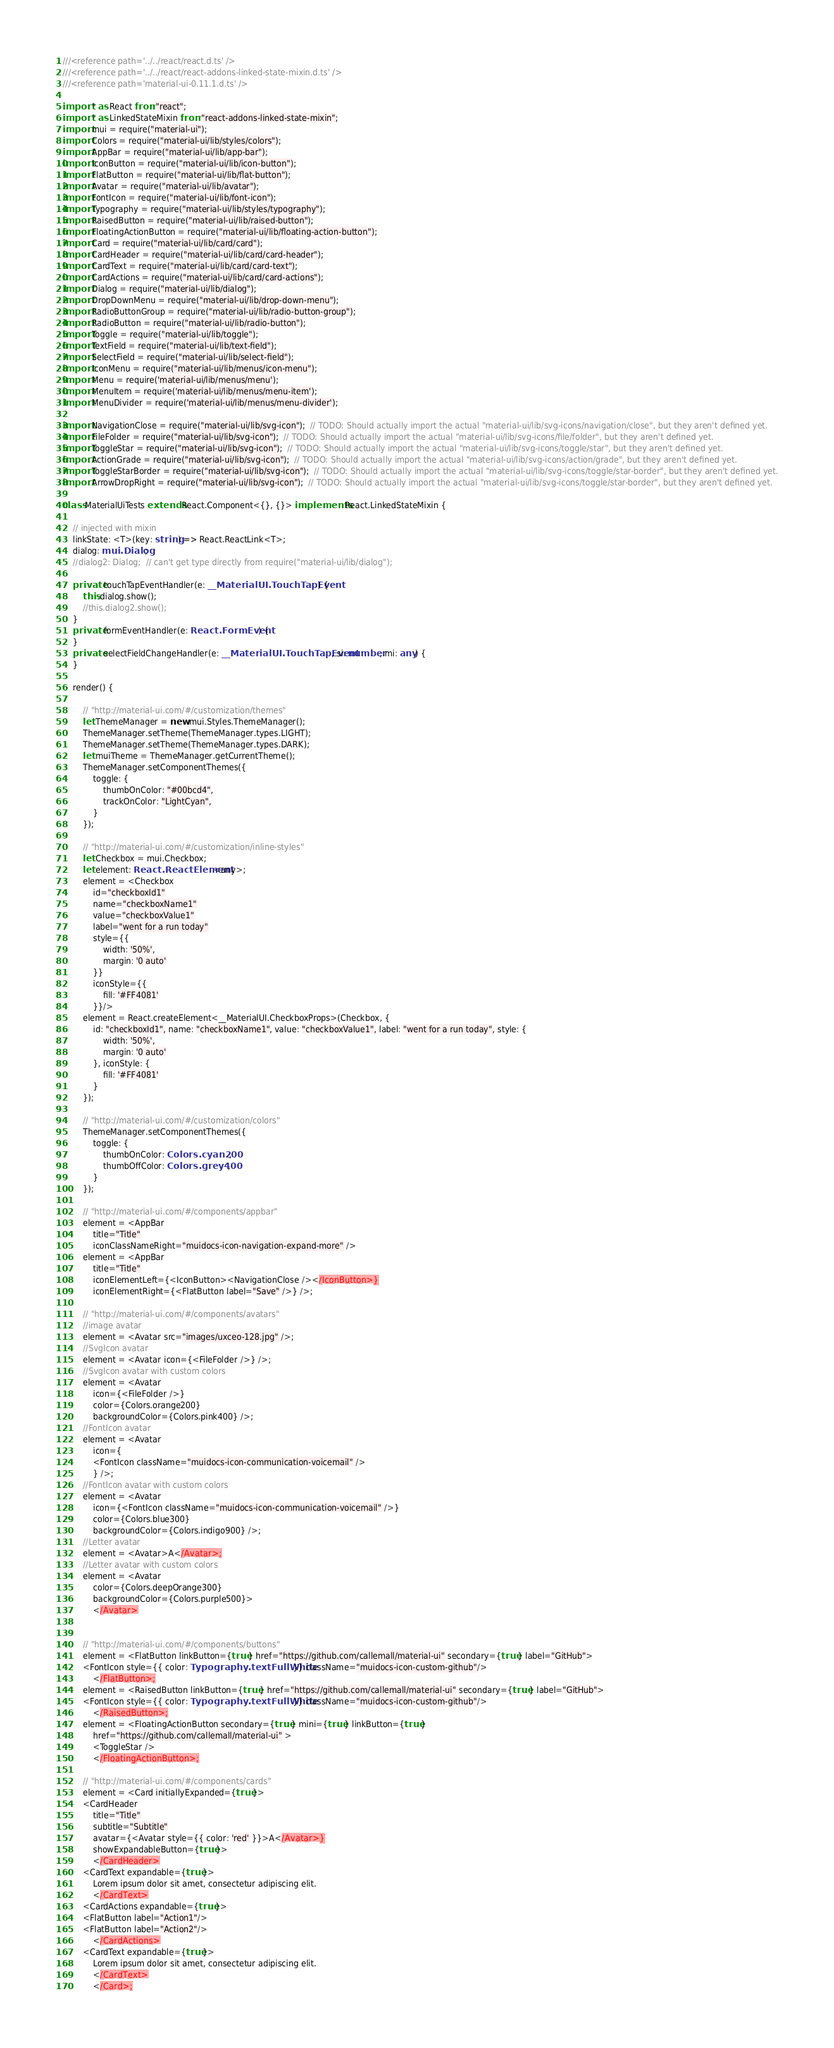Convert code to text. <code><loc_0><loc_0><loc_500><loc_500><_TypeScript_>///<reference path='../../react/react.d.ts' />
///<reference path='../../react/react-addons-linked-state-mixin.d.ts' />
///<reference path='material-ui-0.11.1.d.ts' />

import * as React from "react";
import * as LinkedStateMixin from "react-addons-linked-state-mixin";
import mui = require("material-ui");
import Colors = require("material-ui/lib/styles/colors");
import AppBar = require("material-ui/lib/app-bar");
import IconButton = require("material-ui/lib/icon-button");
import FlatButton = require("material-ui/lib/flat-button");
import Avatar = require("material-ui/lib/avatar");
import FontIcon = require("material-ui/lib/font-icon");
import Typography = require("material-ui/lib/styles/typography");
import RaisedButton = require("material-ui/lib/raised-button");
import FloatingActionButton = require("material-ui/lib/floating-action-button");
import Card = require("material-ui/lib/card/card");
import CardHeader = require("material-ui/lib/card/card-header");
import CardText = require("material-ui/lib/card/card-text");
import CardActions = require("material-ui/lib/card/card-actions");
import Dialog = require("material-ui/lib/dialog");
import DropDownMenu = require("material-ui/lib/drop-down-menu");
import RadioButtonGroup = require("material-ui/lib/radio-button-group");
import RadioButton = require("material-ui/lib/radio-button");
import Toggle = require("material-ui/lib/toggle");
import TextField = require("material-ui/lib/text-field");
import SelectField = require("material-ui/lib/select-field");
import IconMenu = require("material-ui/lib/menus/icon-menu");
import Menu = require('material-ui/lib/menus/menu');
import MenuItem = require('material-ui/lib/menus/menu-item');
import MenuDivider = require('material-ui/lib/menus/menu-divider');

import NavigationClose = require("material-ui/lib/svg-icon");  // TODO: Should actually import the actual "material-ui/lib/svg-icons/navigation/close", but they aren't defined yet.
import FileFolder = require("material-ui/lib/svg-icon");  // TODO: Should actually import the actual "material-ui/lib/svg-icons/file/folder", but they aren't defined yet.
import ToggleStar = require("material-ui/lib/svg-icon");  // TODO: Should actually import the actual "material-ui/lib/svg-icons/toggle/star", but they aren't defined yet.
import ActionGrade = require("material-ui/lib/svg-icon");  // TODO: Should actually import the actual "material-ui/lib/svg-icons/action/grade", but they aren't defined yet.
import ToggleStarBorder = require("material-ui/lib/svg-icon");  // TODO: Should actually import the actual "material-ui/lib/svg-icons/toggle/star-border", but they aren't defined yet.
import ArrowDropRight = require("material-ui/lib/svg-icon");  // TODO: Should actually import the actual "material-ui/lib/svg-icons/toggle/star-border", but they aren't defined yet.

class MaterialUiTests extends React.Component<{}, {}> implements React.LinkedStateMixin {

    // injected with mixin
    linkState: <T>(key: string) => React.ReactLink<T>;
    dialog: mui.Dialog;
    //dialog2: Dialog;  // can't get type directly from require("material-ui/lib/dialog");

    private touchTapEventHandler(e: __MaterialUI.TouchTapEvent) {
        this.dialog.show();
        //this.dialog2.show();
    }
    private formEventHandler(e: React.FormEvent) {
    }
    private selectFieldChangeHandler(e: __MaterialUI.TouchTapEvent, si: number, mi: any) {
    }

    render() {

        // "http://material-ui.com/#/customization/themes"
        let ThemeManager = new mui.Styles.ThemeManager();
        ThemeManager.setTheme(ThemeManager.types.LIGHT);
        ThemeManager.setTheme(ThemeManager.types.DARK);
        let muiTheme = ThemeManager.getCurrentTheme();
        ThemeManager.setComponentThemes({
            toggle: {
                thumbOnColor: "#00bcd4",
                trackOnColor: "LightCyan",
            }
        });

        // "http://material-ui.com/#/customization/inline-styles"
        let Checkbox = mui.Checkbox;
        let element: React.ReactElement<any>;
        element = <Checkbox
            id="checkboxId1"
            name="checkboxName1"
            value="checkboxValue1"
            label="went for a run today"
            style={{
                width: '50%',
                margin: '0 auto'
            }}
            iconStyle={{
                fill: '#FF4081'
            }}/>
        element = React.createElement<__MaterialUI.CheckboxProps>(Checkbox, {
            id: "checkboxId1", name: "checkboxName1", value: "checkboxValue1", label: "went for a run today", style: {
                width: '50%',
                margin: '0 auto'
            }, iconStyle: {
                fill: '#FF4081'
            }
        });

        // "http://material-ui.com/#/customization/colors"
        ThemeManager.setComponentThemes({
            toggle: {
                thumbOnColor: Colors.cyan200,
                thumbOffColor: Colors.grey400,
            }
        });

        // "http://material-ui.com/#/components/appbar"
        element = <AppBar
            title="Title"
            iconClassNameRight="muidocs-icon-navigation-expand-more" />
        element = <AppBar
            title="Title"
            iconElementLeft={<IconButton><NavigationClose /></IconButton>}
            iconElementRight={<FlatButton label="Save" />} />;

        // "http://material-ui.com/#/components/avatars"
        //image avatar
        element = <Avatar src="images/uxceo-128.jpg" />;
        //SvgIcon avatar
        element = <Avatar icon={<FileFolder />} />;
        //SvgIcon avatar with custom colors
        element = <Avatar
            icon={<FileFolder />}
            color={Colors.orange200}
            backgroundColor={Colors.pink400} />;
        //FontIcon avatar
        element = <Avatar
            icon={
            <FontIcon className="muidocs-icon-communication-voicemail" />
            } />;
        //FontIcon avatar with custom colors
        element = <Avatar
            icon={<FontIcon className="muidocs-icon-communication-voicemail" />}
            color={Colors.blue300}
            backgroundColor={Colors.indigo900} />;
        //Letter avatar
        element = <Avatar>A</Avatar>;
        //Letter avatar with custom colors
        element = <Avatar
            color={Colors.deepOrange300}
            backgroundColor={Colors.purple500}>
            </Avatar>


        // "http://material-ui.com/#/components/buttons"
        element = <FlatButton linkButton={true} href="https://github.com/callemall/material-ui" secondary={true} label="GitHub">
        <FontIcon style={{ color: Typography.textFullWhite }} className="muidocs-icon-custom-github"/>
            </FlatButton>;
        element = <RaisedButton linkButton={true} href="https://github.com/callemall/material-ui" secondary={true} label="GitHub">
        <FontIcon style={{ color: Typography.textFullWhite }} className="muidocs-icon-custom-github"/>
            </RaisedButton>;
        element = <FloatingActionButton secondary={true} mini={true} linkButton={true}
            href="https://github.com/callemall/material-ui" >
            <ToggleStar />
            </FloatingActionButton>;

        // "http://material-ui.com/#/components/cards"
        element = <Card initiallyExpanded={true}>
        <CardHeader
            title="Title"
            subtitle="Subtitle"
            avatar={<Avatar style={{ color: 'red' }}>A</Avatar>}
            showExpandableButton={true}>
            </CardHeader>
        <CardText expandable={true}>
            Lorem ipsum dolor sit amet, consectetur adipiscing elit.
            </CardText>
        <CardActions expandable={true}>
        <FlatButton label="Action1"/>
        <FlatButton label="Action2"/>
            </CardActions>
        <CardText expandable={true}>
            Lorem ipsum dolor sit amet, consectetur adipiscing elit.
            </CardText>
            </Card>;
</code> 